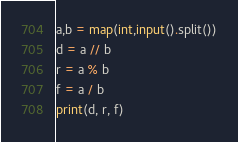Convert code to text. <code><loc_0><loc_0><loc_500><loc_500><_Python_>a,b = map(int,input().split())
d = a // b
r = a % b
f = a / b
print(d, r, f)</code> 